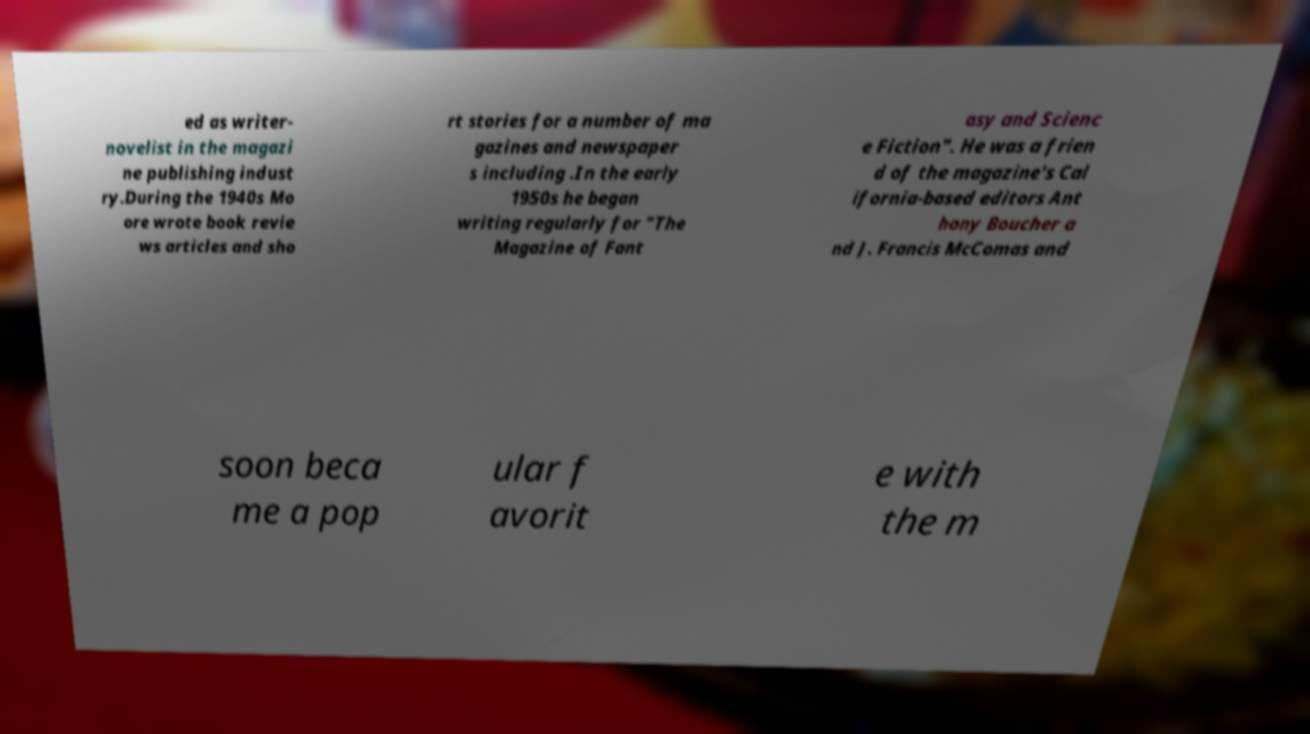Could you assist in decoding the text presented in this image and type it out clearly? ed as writer- novelist in the magazi ne publishing indust ry.During the 1940s Mo ore wrote book revie ws articles and sho rt stories for a number of ma gazines and newspaper s including .In the early 1950s he began writing regularly for "The Magazine of Fant asy and Scienc e Fiction". He was a frien d of the magazine's Cal ifornia-based editors Ant hony Boucher a nd J. Francis McComas and soon beca me a pop ular f avorit e with the m 